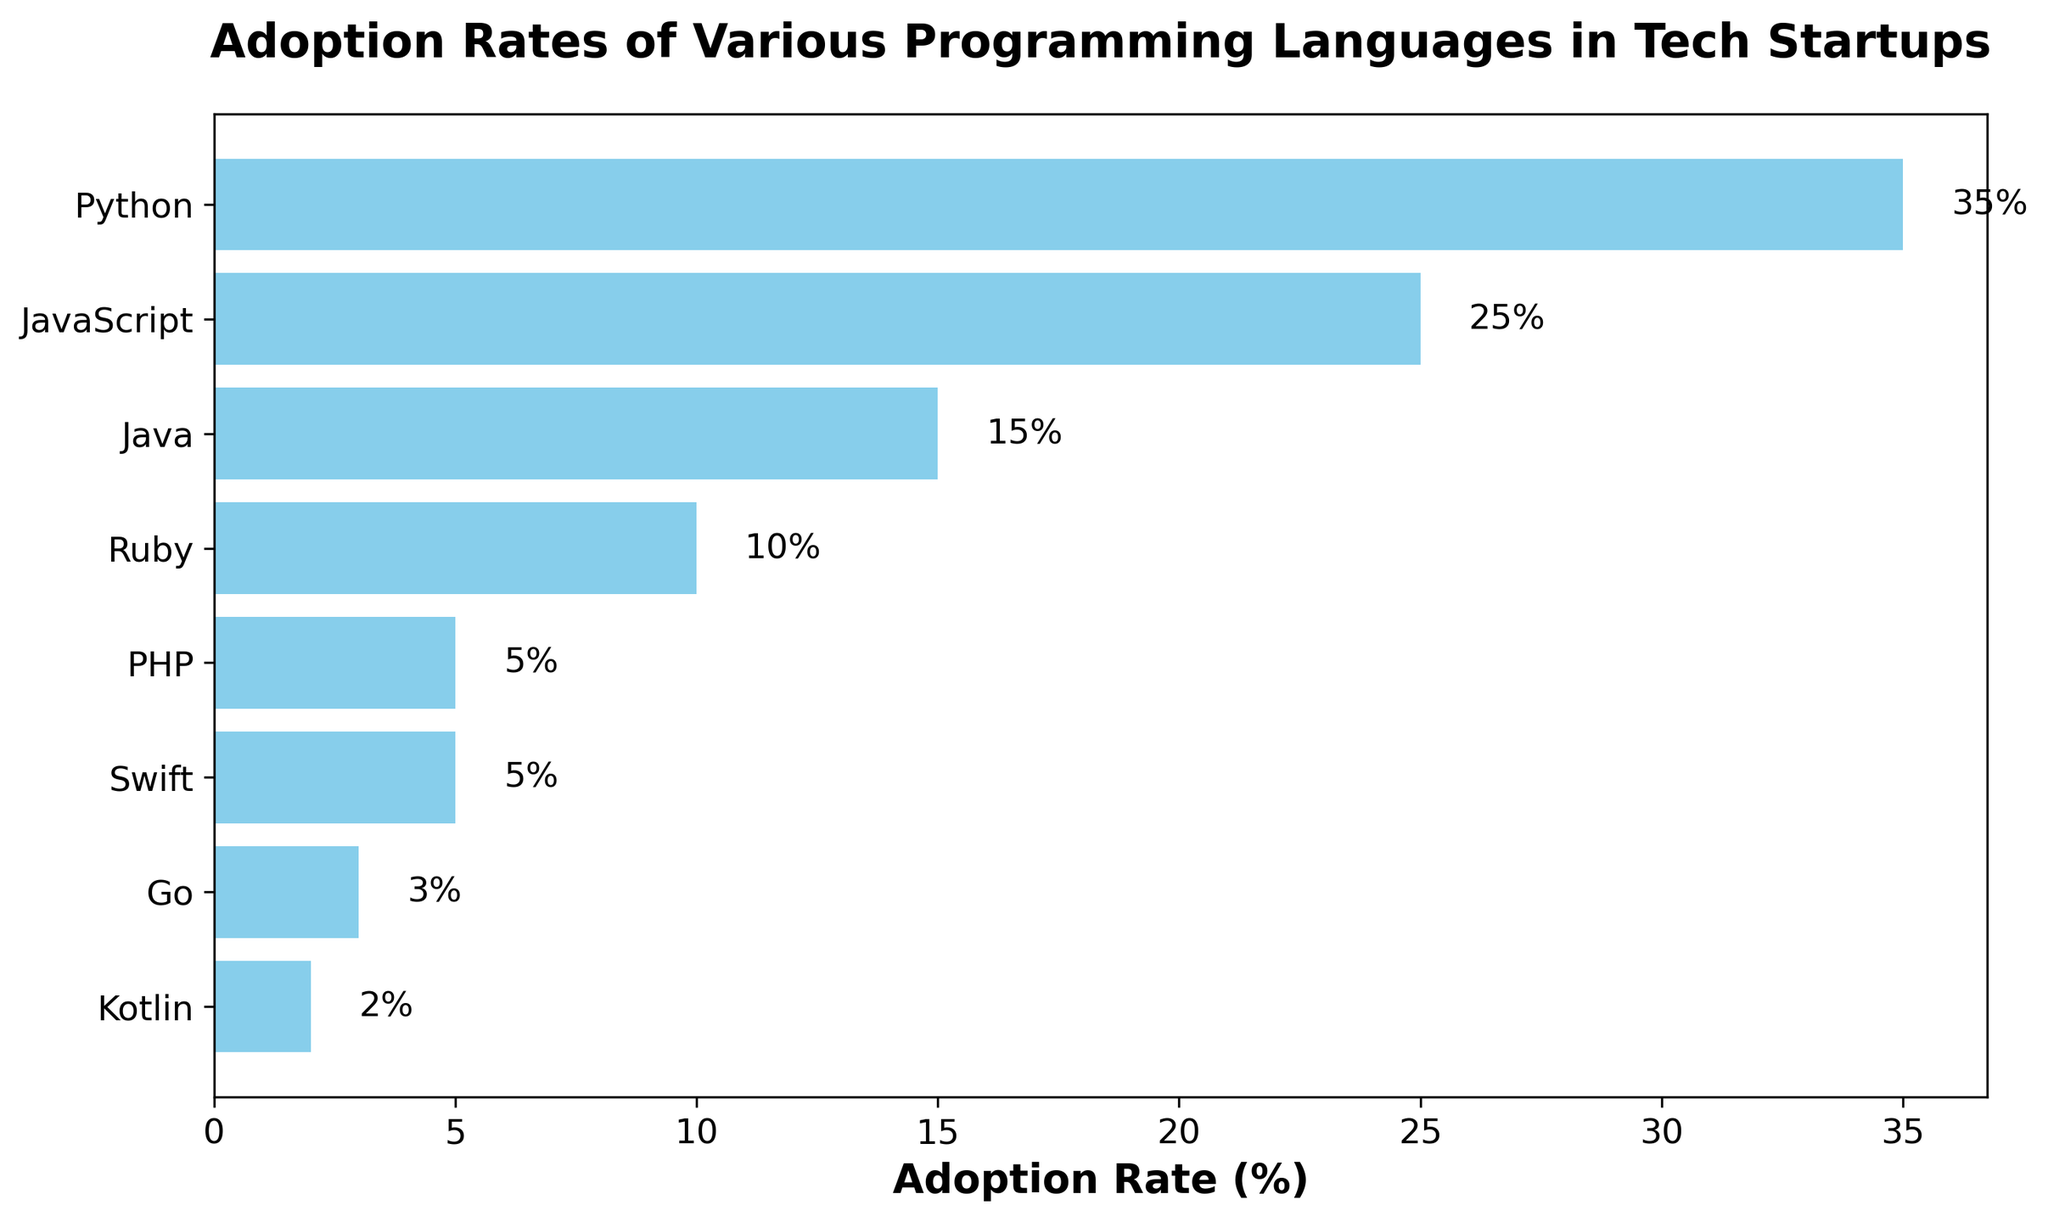What programming language has the highest adoption rate? First, identify the language with the tallest bar on the bar chart. Secondly, note that Python has the tallest bar, indicating the highest adoption rate at 35%.
Answer: Python Which two languages have the same adoption rate? Look for bars of equal length. Both PHP and Swift are represented by bars of the same length, 5%, indicating that these two languages have the same adoption rate.
Answer: PHP and Swift What is the difference in adoption rate between Python and Java? First, determine the adoption rates of Python and Java from the bar chart, which are 35% and 15% respectively. Then, subtract the smaller value from the larger value: 35% - 15% = 20%.
Answer: 20% Which language has the lowest adoption rate? Identify the language with the shortest bar on the chart. Kotlin, with an adoption rate of 2%, has the shortest bar and thus the lowest adoption rate.
Answer: Kotlin How much higher is the adoption rate of JavaScript compared to Ruby? Determine the adoption rates for JavaScript and Ruby, which are 25% and 10%, respectively. Subtract the lower rate from the higher rate: 25% - 10% = 15%.
Answer: 15% What is the combined adoption rate of Go and Kotlin? Locate the adoption rates of Go and Kotlin (3% and 2% respectively). Add these values together: 3% + 2% = 5%.
Answer: 5% What is the average adoption rate of Java, Go, and Kotlin? Find the adoption rates for Java, Go, and Kotlin, which are 15%, 3%, and 2%. Sum these rates: 15% + 3% + 2% = 20%. Divide the sum by the number of rates: 20% / 3 = 6.67%.
Answer: 6.67% Is the adoption rate of Swift greater than or equal to PHP? Compare the adoption rates for Swift and PHP as depicted on the bar chart. Both languages are shown to have an adoption rate of 5%, confirming that Swift's rate is equal to PHP's.
Answer: Yes Which language has the second highest adoption rate? Identify the bars and their heights to determine the second highest value after Python. JavaScript, with an adoption rate of 25%, is the language with the second highest rate.
Answer: JavaScript 